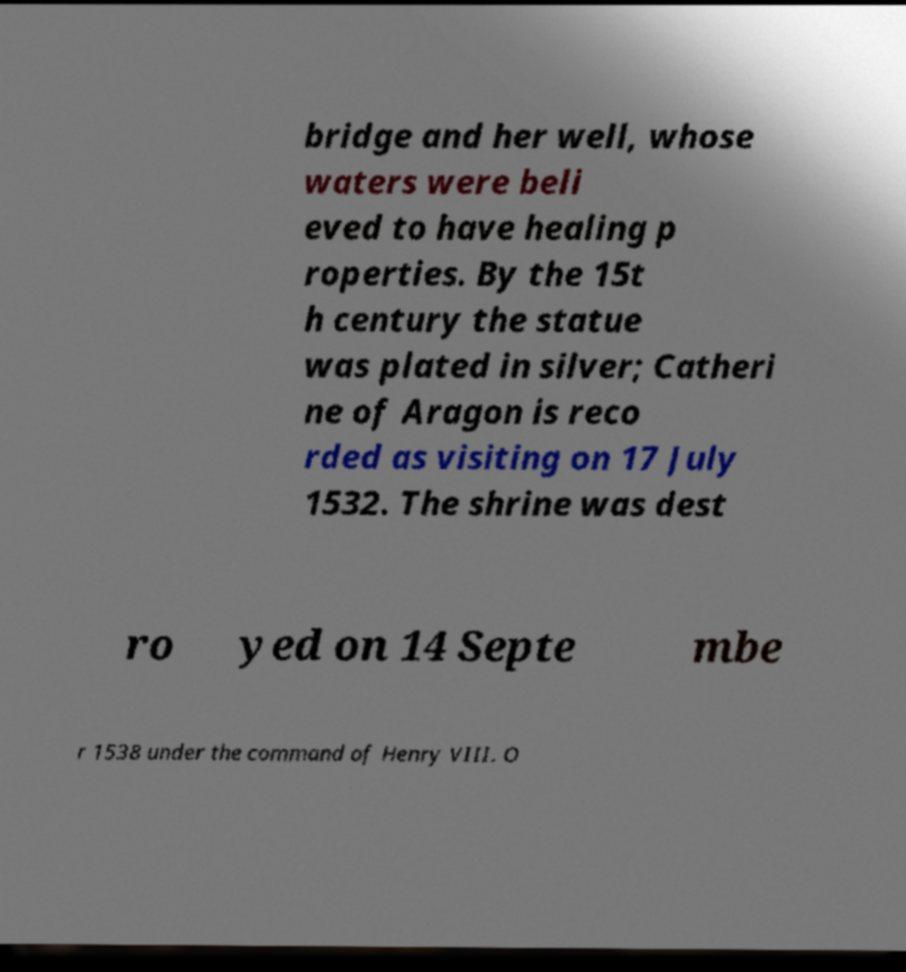What messages or text are displayed in this image? I need them in a readable, typed format. bridge and her well, whose waters were beli eved to have healing p roperties. By the 15t h century the statue was plated in silver; Catheri ne of Aragon is reco rded as visiting on 17 July 1532. The shrine was dest ro yed on 14 Septe mbe r 1538 under the command of Henry VIII. O 